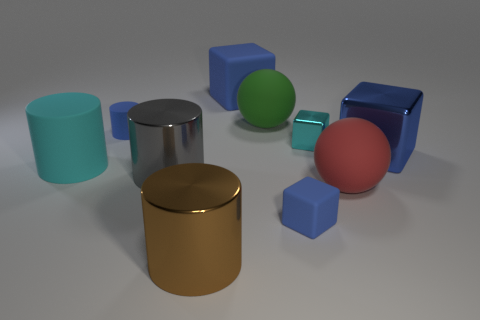What material is the large gray cylinder? The large gray cylinder appears to be made of a polished metal, given its reflective surface and smooth texture which is indicative of materials like steel or aluminum commonly used in manufacturing various objects for their durability and aesthetic appeal. 